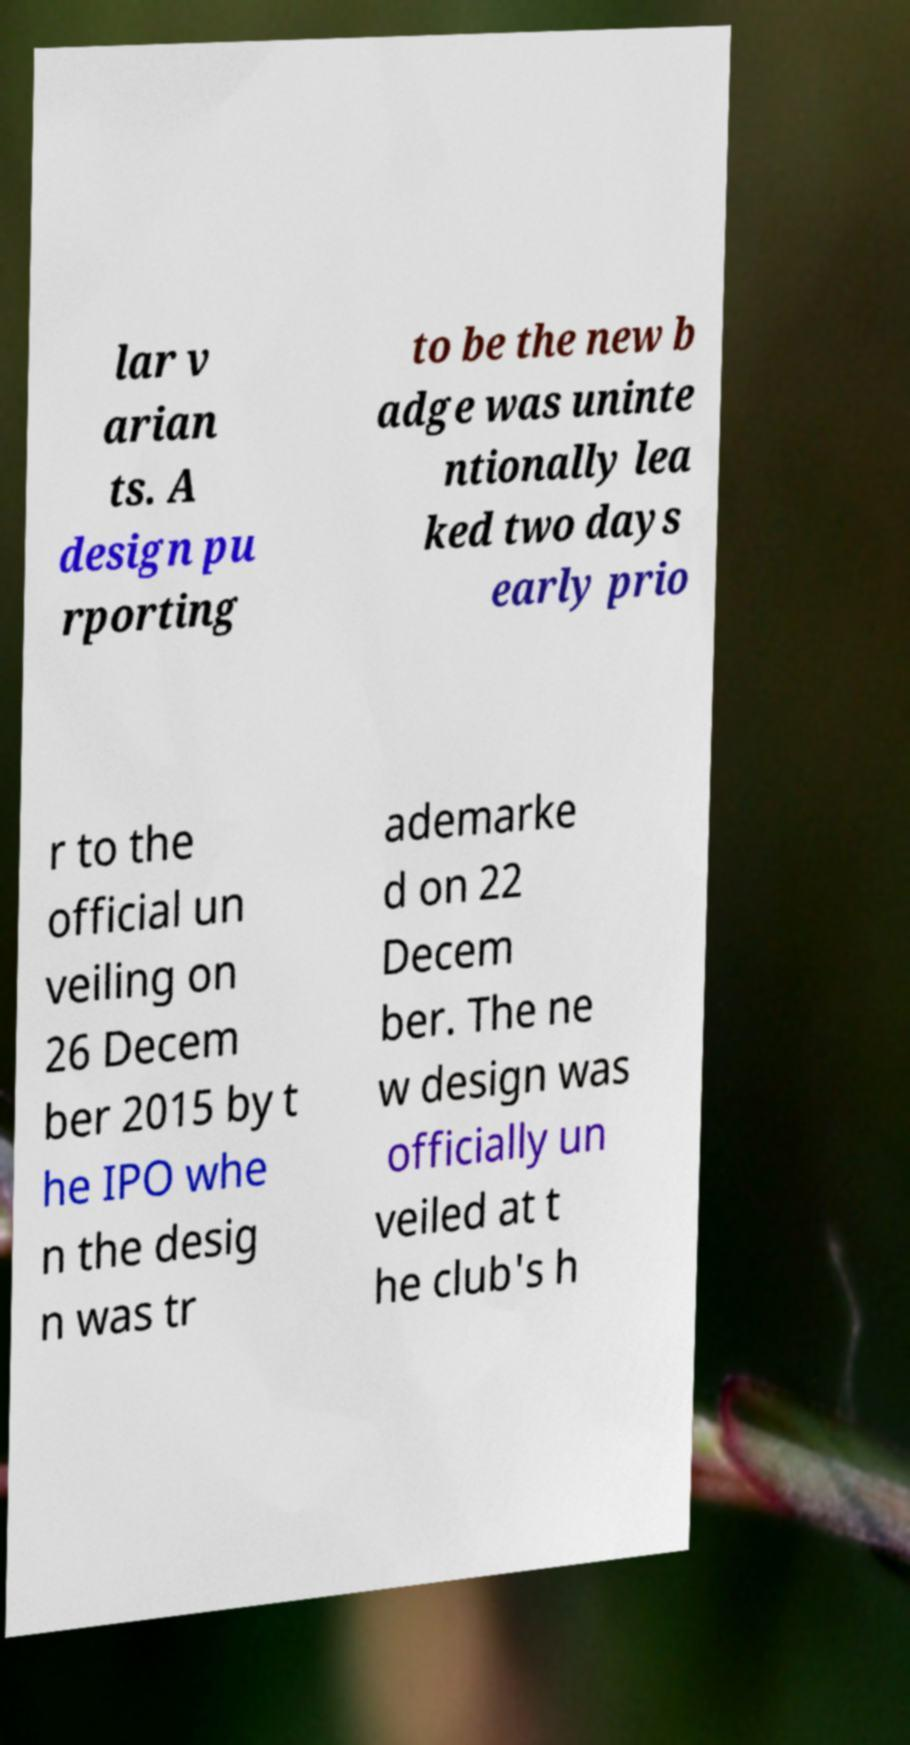Can you read and provide the text displayed in the image?This photo seems to have some interesting text. Can you extract and type it out for me? lar v arian ts. A design pu rporting to be the new b adge was uninte ntionally lea ked two days early prio r to the official un veiling on 26 Decem ber 2015 by t he IPO whe n the desig n was tr ademarke d on 22 Decem ber. The ne w design was officially un veiled at t he club's h 